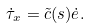Convert formula to latex. <formula><loc_0><loc_0><loc_500><loc_500>\dot { \tau } _ { x } = \tilde { c } ( s ) \dot { e } .</formula> 